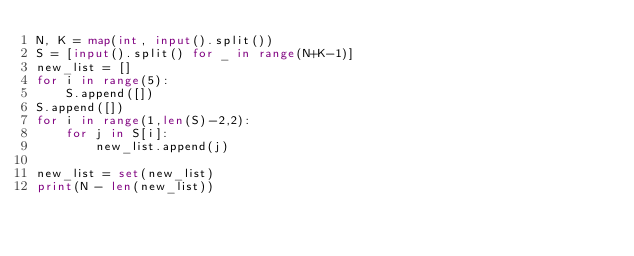<code> <loc_0><loc_0><loc_500><loc_500><_Python_>N, K = map(int, input().split())
S = [input().split() for _ in range(N+K-1)]
new_list = []
for i in range(5):
    S.append([])
S.append([])
for i in range(1,len(S)-2,2):
    for j in S[i]:
        new_list.append(j)

new_list = set(new_list)
print(N - len(new_list))
</code> 